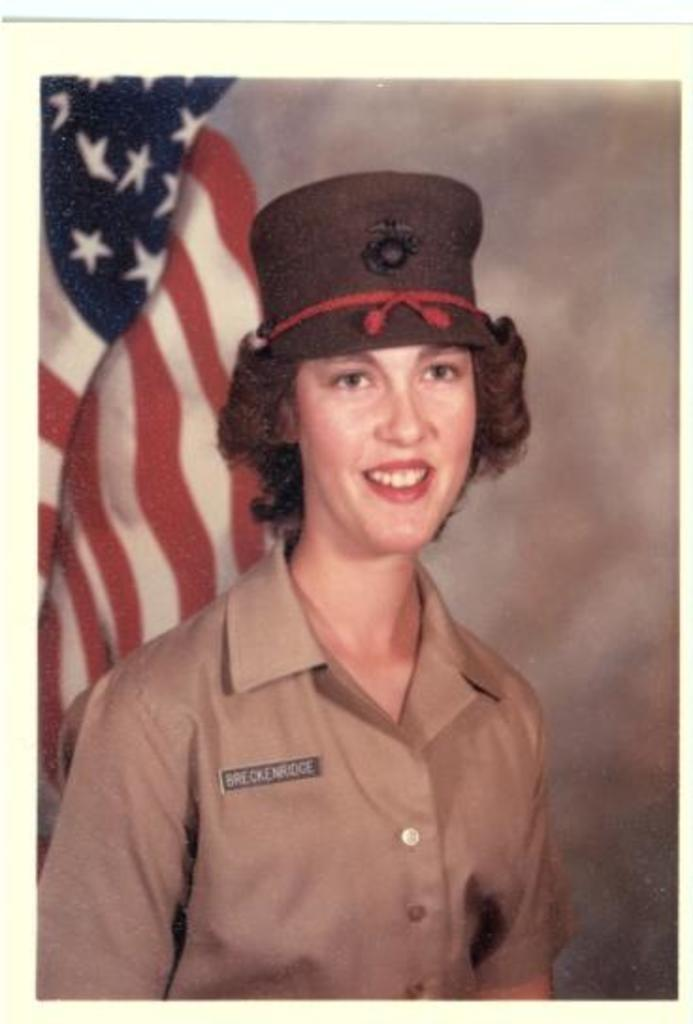What is the main subject of the image? There is a photo in the image. What can be seen in the photo? The photo contains a lady. What is the lady wearing in the photo? The lady is wearing a hat. What is visible in the background of the photo? There is a flag in the background of the photo. What type of lumber is being used to build the cake in the image? There is no cake or lumber present in the image; it features a photo of a lady wearing a hat with a flag in the background. How does the acoustics of the room affect the lady's hat in the image? The image does not provide any information about the acoustics of the room, and the lady's hat is not affected by any acoustics. 